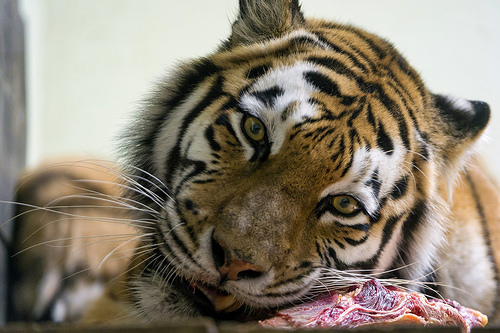<image>
Is the tiger eye behind the eye two? No. The tiger eye is not behind the eye two. From this viewpoint, the tiger eye appears to be positioned elsewhere in the scene. 